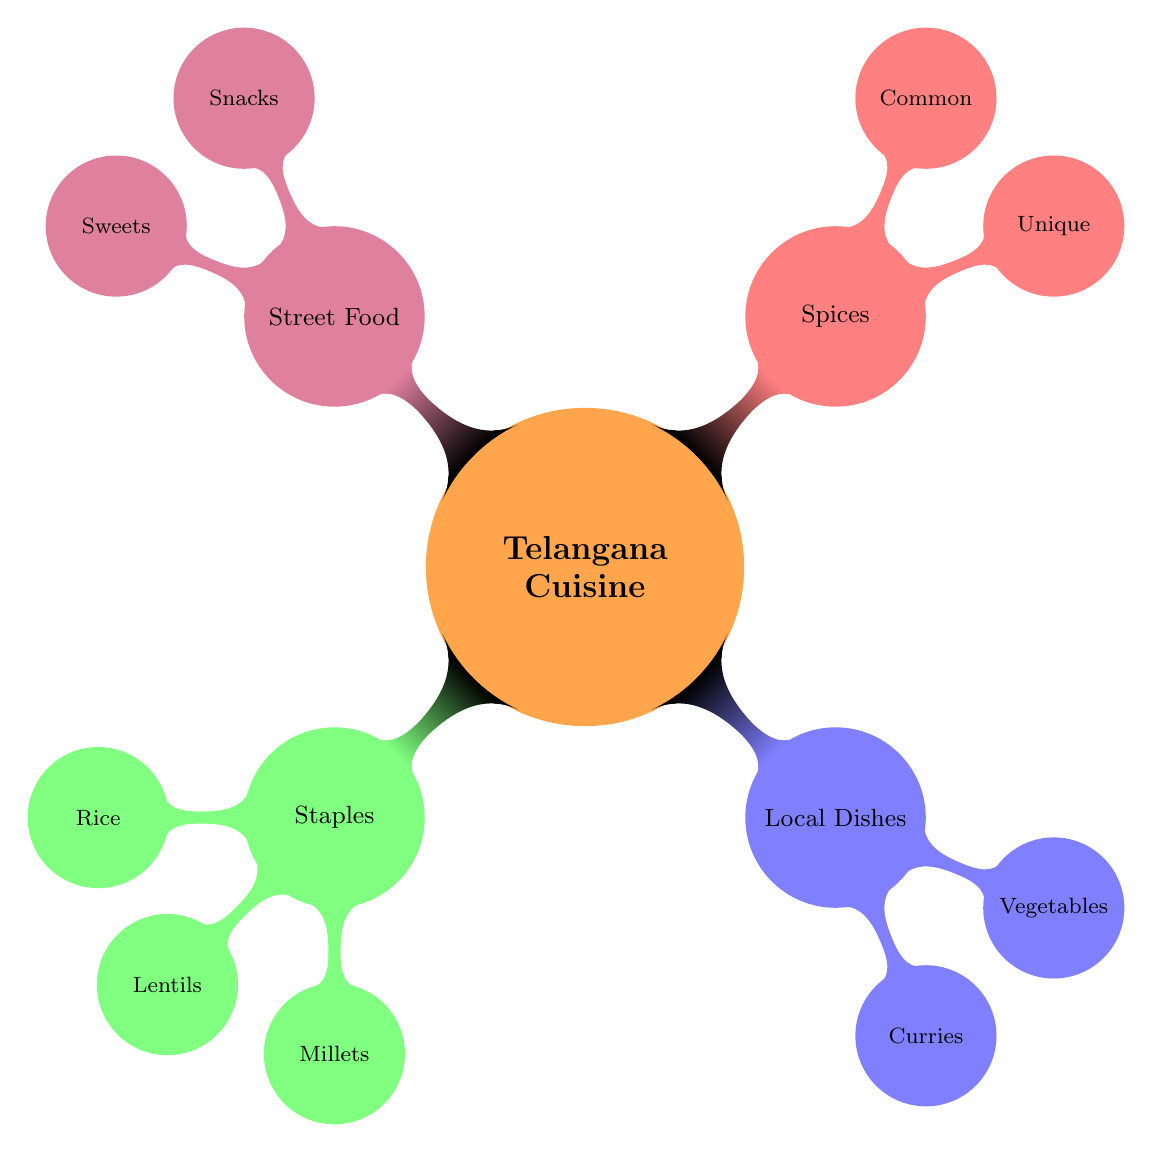What are the staples of Telangana cuisine? The diagram lists staples as a main category, which includes rice, lentils, and millets. These are directly shown under the "Staples" node.
Answer: Rice, Lentils, Millets Which curry is mentioned under local dishes? The "Curries" node under "Local Dishes" includes two examples: Gongura Mutton and Kodi Kura. Hence, picking any of these would be a valid answer for the question.
Answer: Gongura Mutton How many types of street food are highlighted? The "Street Food" node contains two child nodes: "Snacks" and "Sweets". Thus, the total number of subcategories for street food is two.
Answer: 2 What is a unique spice used in Telangana cuisine? Under the "Spices" node, there is a category labeled "Unique Spices", from which tamarind is specifically mentioned.
Answer: Tamarind Which staple has both biryani and pulihora as examples? The "Rice" node under "Staples" shows both biryani and pulihora as examples of rice dishes. By locating the "Rice" node, one can easily find these examples.
Answer: Biryani, Pulihora What are the two categories of spices listed in the diagram? The "Spices" node contains two subcategories labeled "Unique" and "Common". These represent the types of spices mentioned in the context of Telangana cuisine.
Answer: Unique, Common Which local dish is made from vegetables? Under the "Vegetables" node in "Local Dishes", Aaku Koora and Gutti Vankaya are mentioned as examples of vegetable dishes. Thus, referring to this node leads to the answer.
Answer: Aaku Koora, Gutti Vankaya What type of sweet is featured in the street food section? Looking under the "Sweets" node in the "Street Food" category, Qubani Ka Meetha is one item listed there, indicating it as a featured sweet in Telangana street food.
Answer: Qubani Ka Meetha 